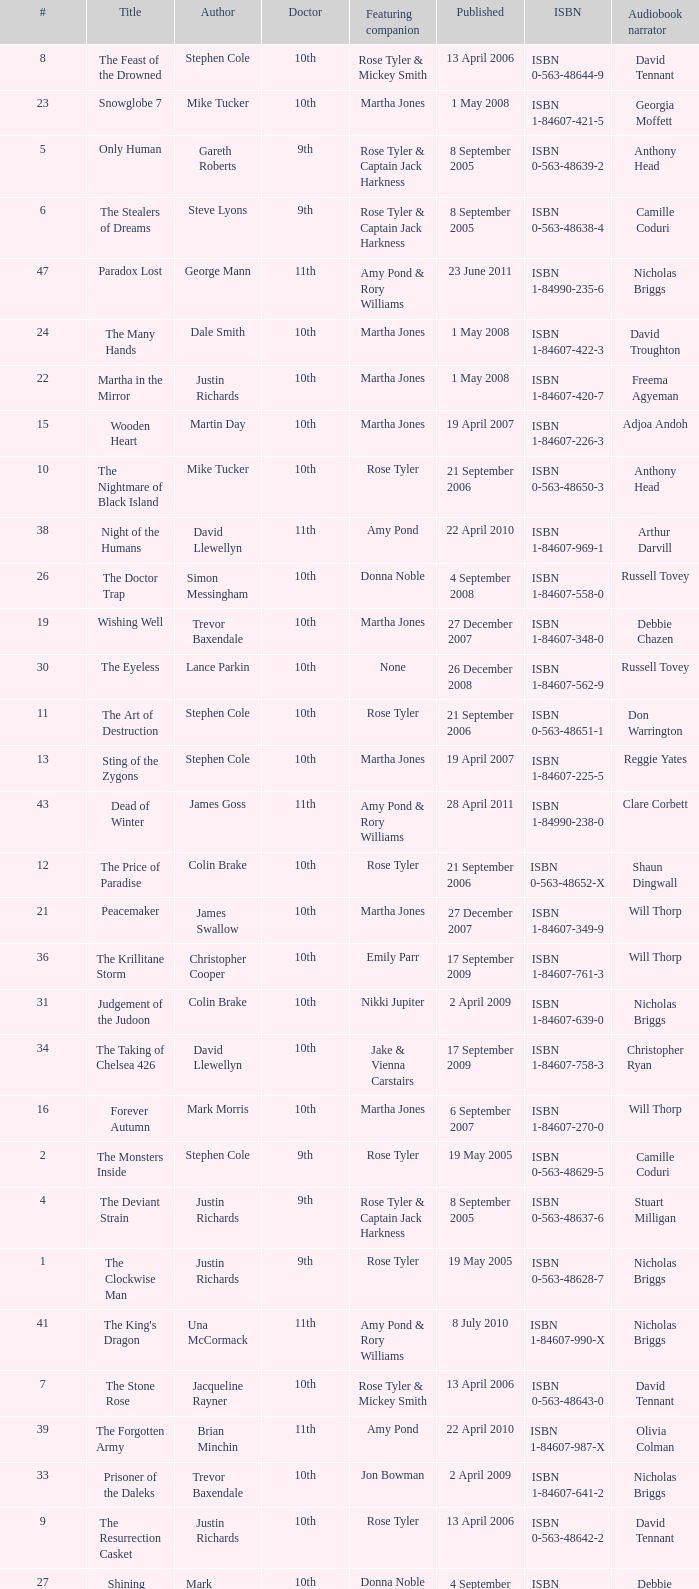Who are the featuring companions of number 3? Rose Tyler & Mickey Smith. 